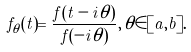<formula> <loc_0><loc_0><loc_500><loc_500>f _ { \theta } ( t ) = \frac { f ( t - i \theta ) } { f ( - i \theta ) } , \, \theta \in [ a , b ] .</formula> 